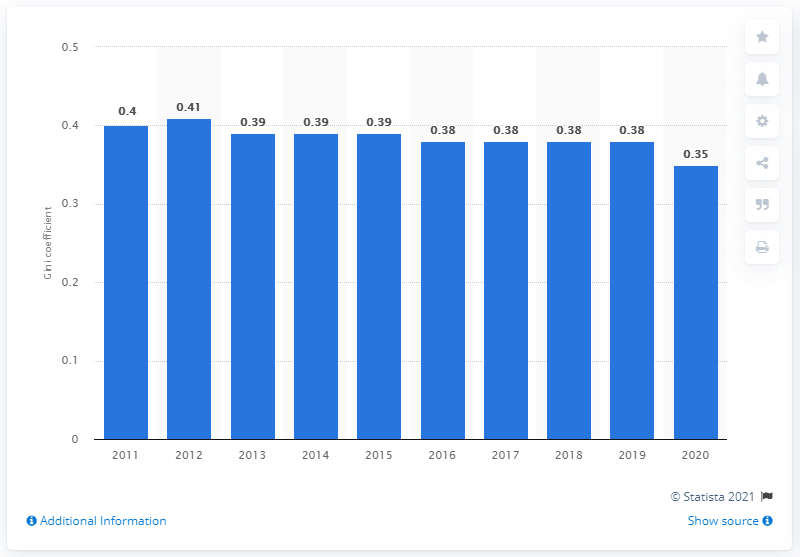Highlight a few significant elements in this photo. In 2012, the Gini coefficient index score for Singapore was 0.41, indicating a moderate level of income inequality. The Gini coefficient after taxes in Singapore in 2020 was 0.35, indicating a moderate degree of income inequality. In 2013, the Gini coefficient decreased. 